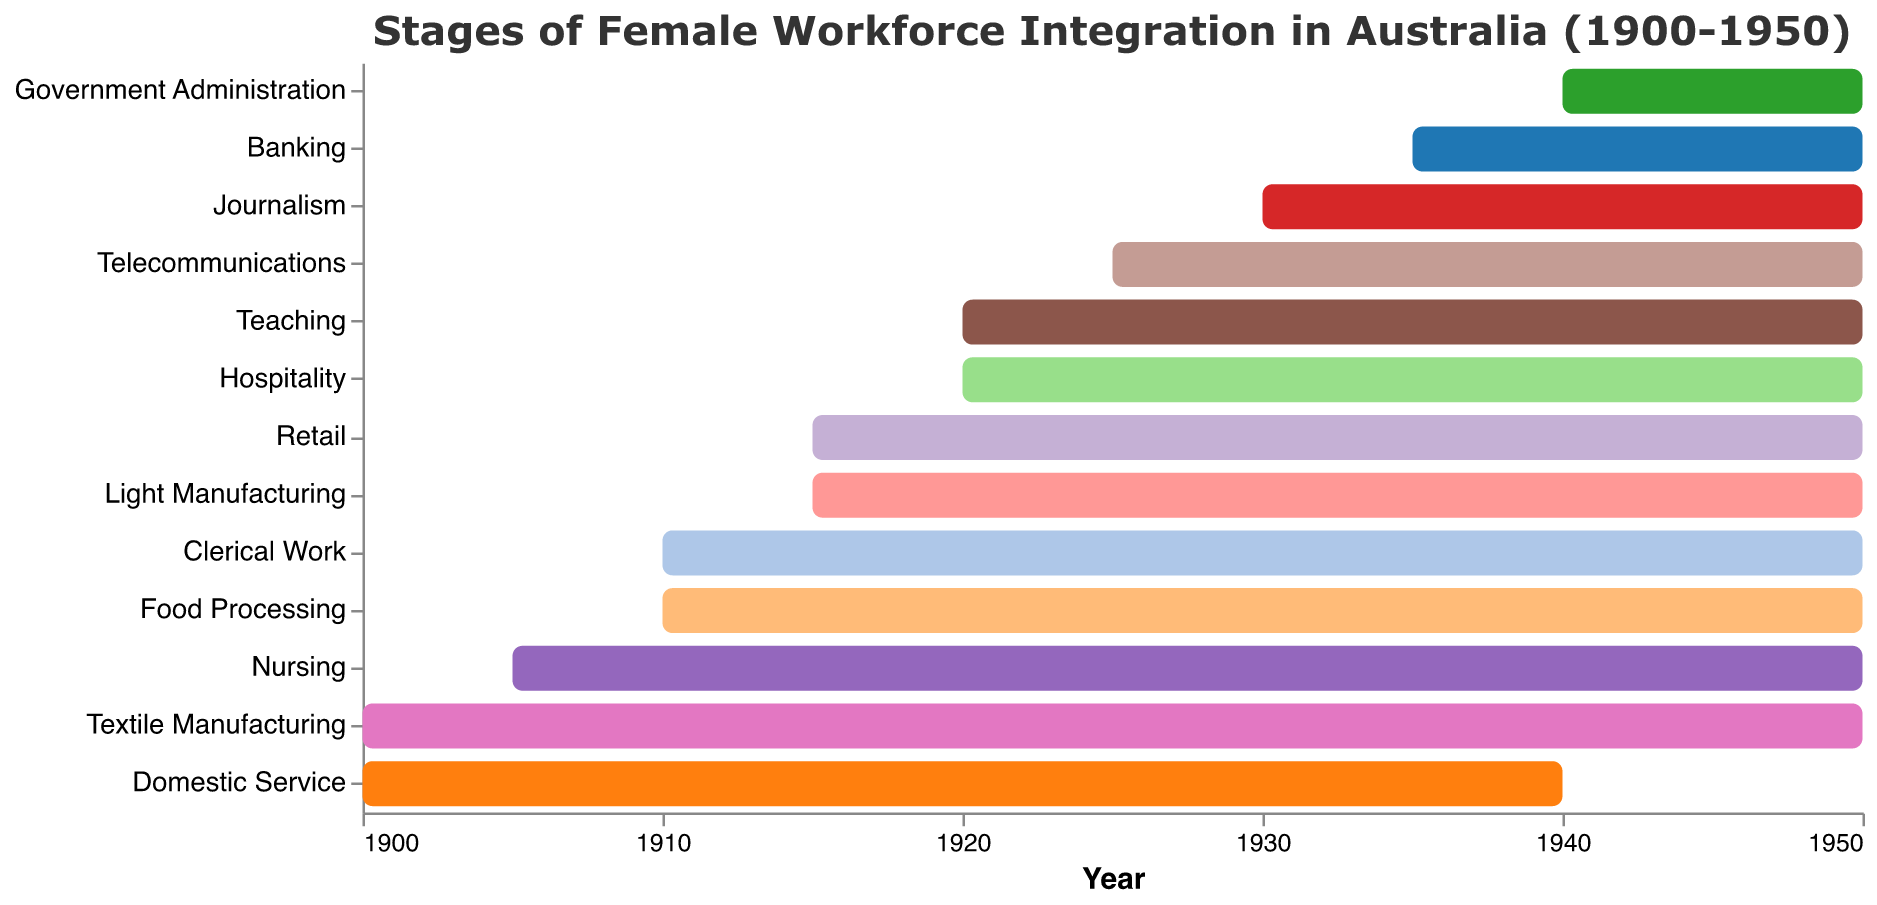Which industry saw female workforce integration from the earliest? The figure shows the start year for each industry. Textile Manufacturing and Domestic Service both started in 1900.
Answer: Textile Manufacturing and Domestic Service Which industries saw female workforce integration last? The figure shows the end year for each industry. Government Administration, starting in 1940, is the last one to see female workforce integration.
Answer: Government Administration Which industry had female workforce integration both start and end the latest? First, identify the latest start year and the latest end year. Banking had its integration start in 1935 and end in 1950.
Answer: Banking How long did female workforce integration last in the Telecommunications industry? Find the difference between the start year (1925) and the end year (1950). 1950 - 1925 = 25 years.
Answer: 25 years Which industry saw female workforce integration for the shortest period? Find the difference between the start and end years for each industry, the shortest integration is Domestic Service from 1900 to 1940. 1940 - 1900 = 40 years.
Answer: Domestic Service What was the average duration of female workforce integration across all industries? Calculate the durations for all industries, sum them up, and divide by the number of industries. ((50 + (1950-1910) + (1950-1915) + (1950-1920) + ...+ (1950-1940))/13). You can convert "1950-Start Year" directly.
Answer: ~34.6 years Did female workforce integration in any industry end before 1950? Which ones? The figure shows the end year for each industry. Only Domestic Service ended in 1940.
Answer: Domestic Service Which industry had the second-longest period of female workforce integration? Calculate the duration for each industry and arrange them. Nursing had integration from 1905 to 1950 which is 45 years, second only to Textile Manufacturing.
Answer: Nursing 